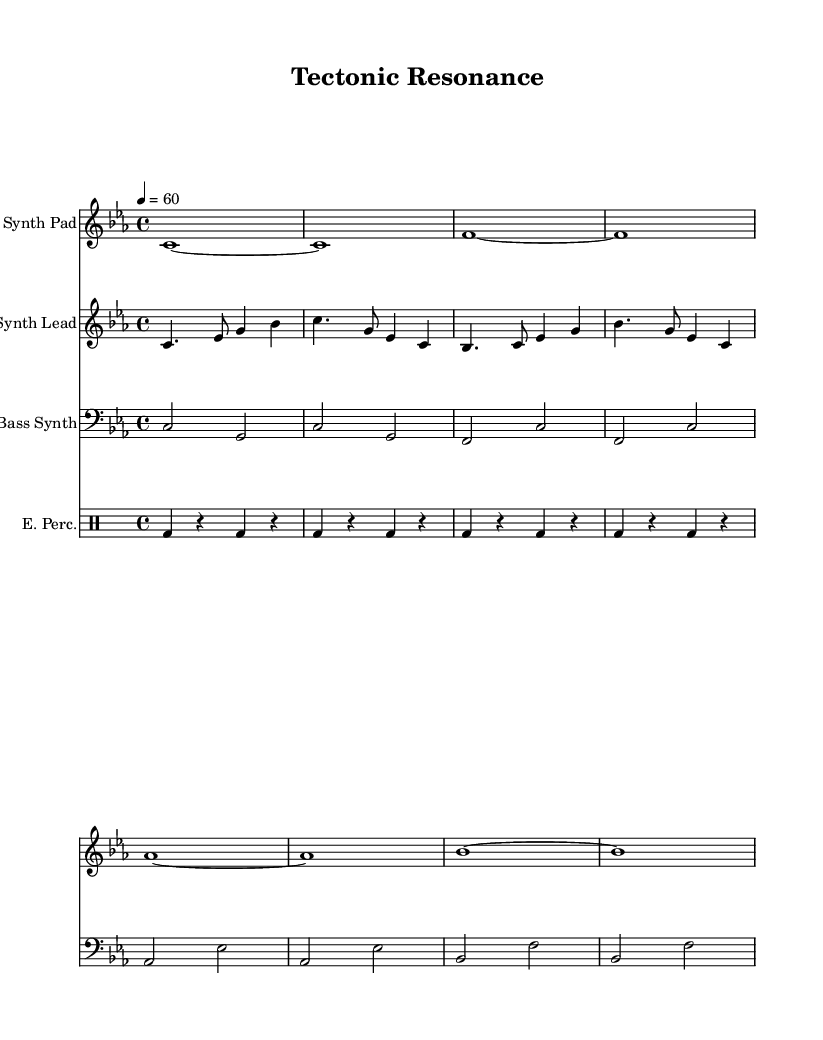What is the key signature of this music? The key signature in the sheet music shows no sharps or flats, indicating it is in C minor.
Answer: C minor What is the time signature of this piece? The time signature is indicated at the beginning of the score, and it shows 4 over 4, which means there are four beats in a measure.
Answer: 4/4 What is the tempo of the piece? The tempo marking specifies that the quarter note should be played at 60 beats per minute, which sets the pace for the music.
Answer: 60 How many instruments are used in this score? By counting the different staffs in the score, we see that four distinct instruments are used: a synth pad, synth lead, bass synth, and electronic percussion.
Answer: Four Which instrument has the lowest pitch range in this score? The bass synth is written in the bass clef, indicating it plays in a lower pitch range compared to the other instruments.
Answer: Bass Synth What musical form or structure can be inferred from the piece? The repetitive nature of the synth pad and percussion suggests an ambient electronic form, which typically relies on loops and evolving textures rather than traditional song structure.
Answer: Ambient electronic form What is the significance of the musical elements found in this piece related to geophysical phenomena? The composition uses wave patterns and rhythms that reflect seismic activity, creating a sonic representation of tectonic movements and natural forces through the electronic sounds.
Answer: Sonic representation of geophysical phenomena 